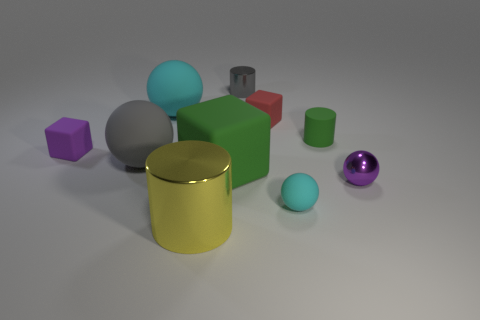Subtract all balls. How many objects are left? 6 Subtract 1 gray cylinders. How many objects are left? 9 Subtract all large yellow matte balls. Subtract all big gray rubber objects. How many objects are left? 9 Add 9 tiny cyan objects. How many tiny cyan objects are left? 10 Add 10 large cyan matte blocks. How many large cyan matte blocks exist? 10 